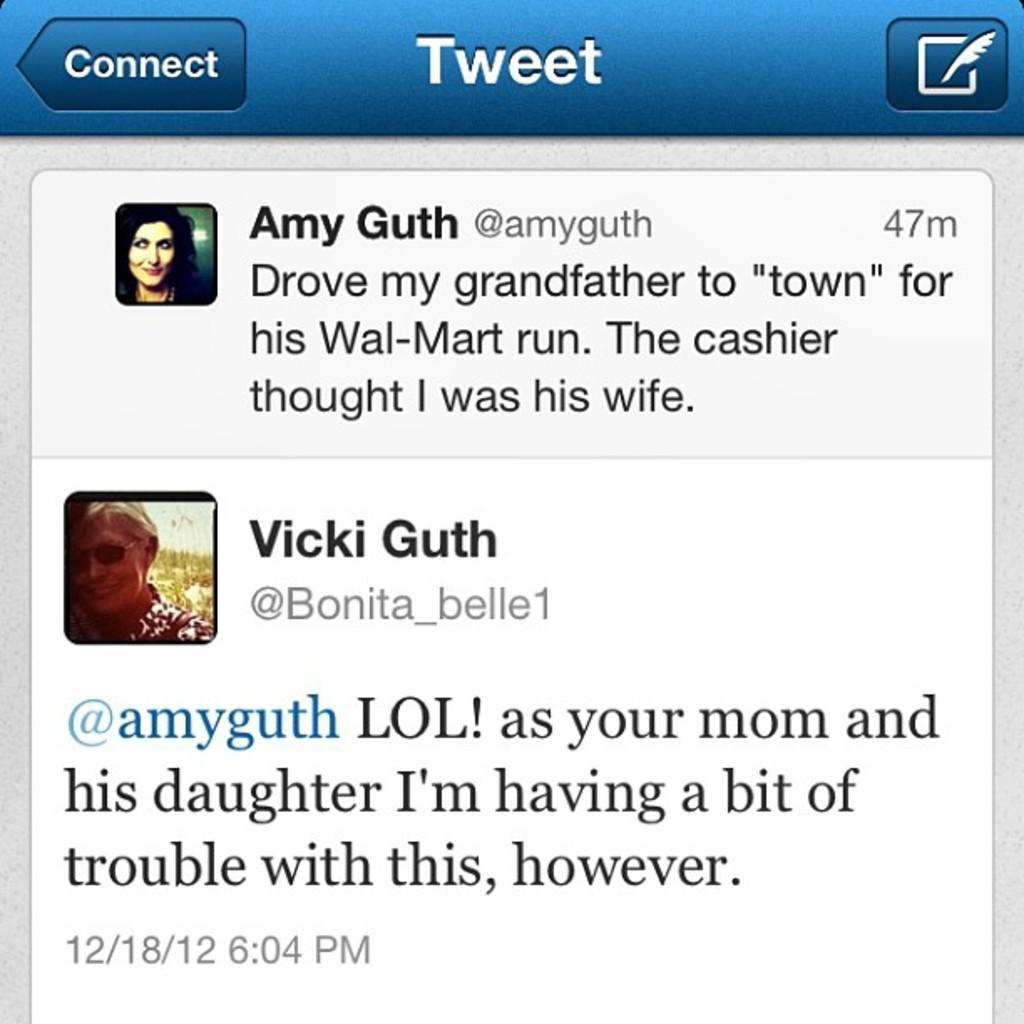Could you give a brief overview of what you see in this image? This is a poster. In this image there is some text, behind the text there is an image of a person. 